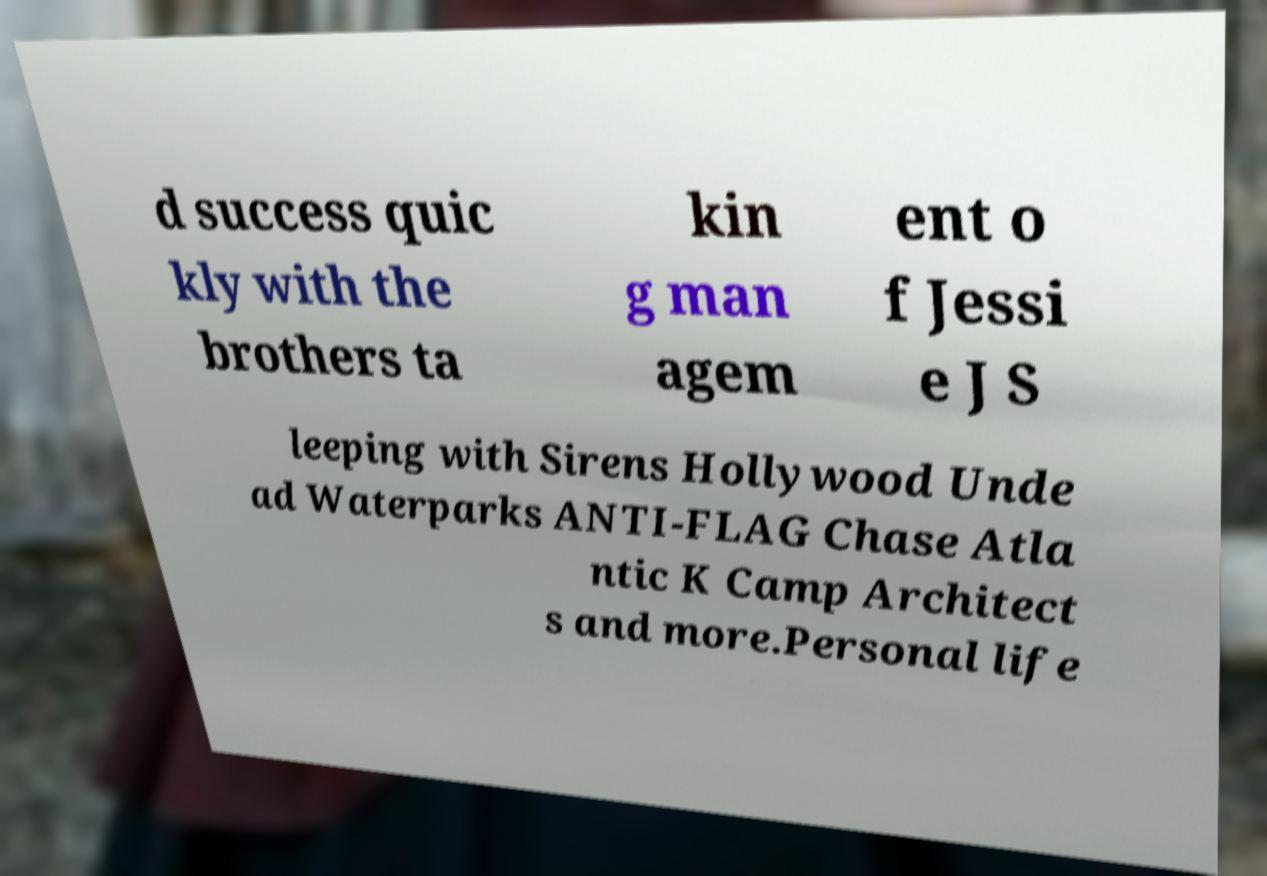Could you extract and type out the text from this image? d success quic kly with the brothers ta kin g man agem ent o f Jessi e J S leeping with Sirens Hollywood Unde ad Waterparks ANTI-FLAG Chase Atla ntic K Camp Architect s and more.Personal life 